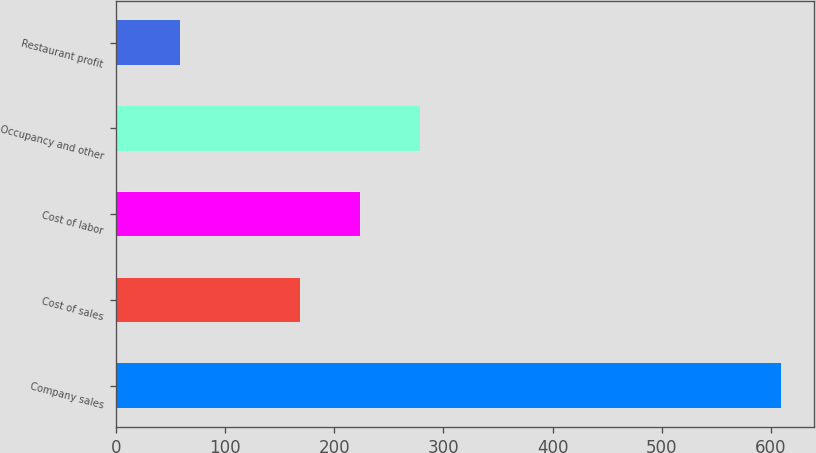Convert chart to OTSL. <chart><loc_0><loc_0><loc_500><loc_500><bar_chart><fcel>Company sales<fcel>Cost of sales<fcel>Cost of labor<fcel>Occupancy and other<fcel>Restaurant profit<nl><fcel>609<fcel>169<fcel>224<fcel>279<fcel>59<nl></chart> 